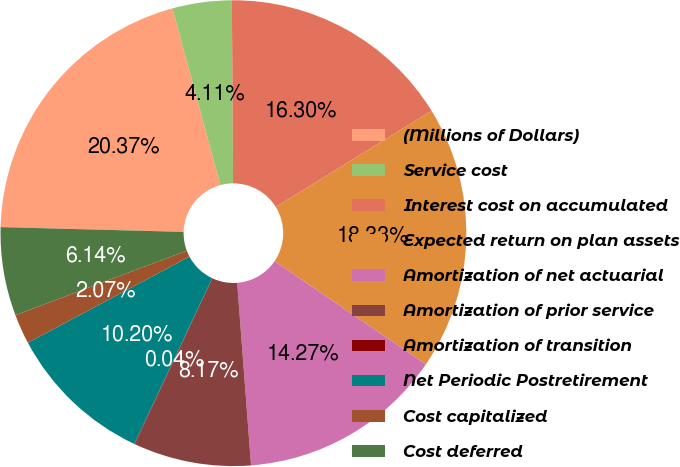Convert chart to OTSL. <chart><loc_0><loc_0><loc_500><loc_500><pie_chart><fcel>(Millions of Dollars)<fcel>Service cost<fcel>Interest cost on accumulated<fcel>Expected return on plan assets<fcel>Amortization of net actuarial<fcel>Amortization of prior service<fcel>Amortization of transition<fcel>Net Periodic Postretirement<fcel>Cost capitalized<fcel>Cost deferred<nl><fcel>20.37%<fcel>4.11%<fcel>16.3%<fcel>18.33%<fcel>14.27%<fcel>8.17%<fcel>0.04%<fcel>10.2%<fcel>2.07%<fcel>6.14%<nl></chart> 